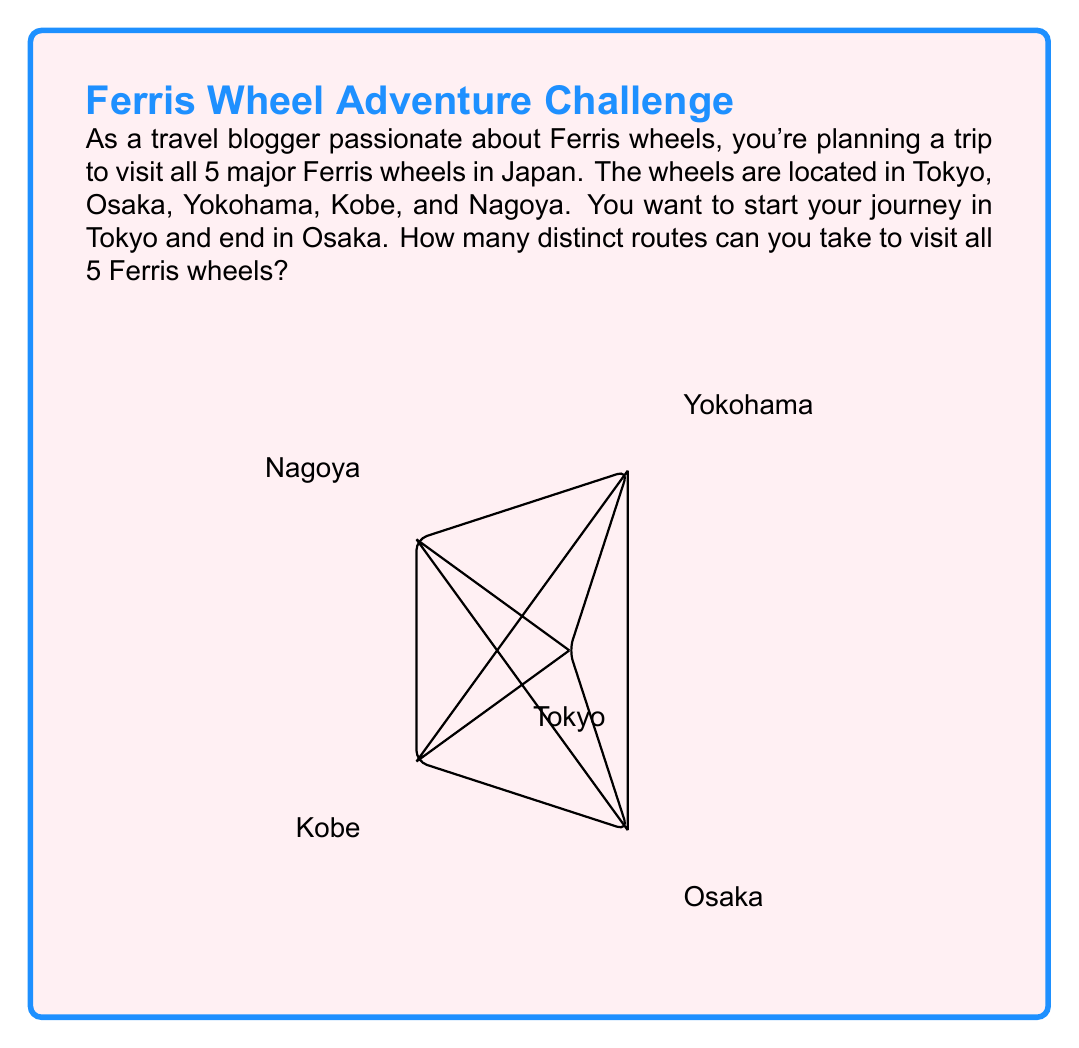Provide a solution to this math problem. Let's approach this step-by-step:

1) We start in Tokyo and end in Osaka, so these cities are fixed at the beginning and end of our route.

2) We need to arrange the other 3 cities (Yokohama, Nagoya, and Kobe) in between Tokyo and Osaka.

3) This is a permutation problem. We're arranging 3 items (the middle cities) in all possible orders.

4) The number of permutations of n distinct objects is given by the factorial of n, denoted as n!

5) In this case, n = 3, so we're calculating 3!

6) 3! = 3 × 2 × 1 = 6

Therefore, the number of distinct routes is 6.

We can list all these routes:
1. Tokyo → Yokohama → Nagoya → Kobe → Osaka
2. Tokyo → Yokohama → Kobe → Nagoya → Osaka
3. Tokyo → Nagoya → Yokohama → Kobe → Osaka
4. Tokyo → Nagoya → Kobe → Yokohama → Osaka
5. Tokyo → Kobe → Yokohama → Nagoya → Osaka
6. Tokyo → Kobe → Nagoya → Yokohama → Osaka

This can be represented mathematically as:

$$\text{Number of routes} = (n-2)! = 3! = 6$$

Where n is the total number of cities (5), and we subtract 2 because the start and end points are fixed.
Answer: 6 